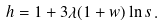<formula> <loc_0><loc_0><loc_500><loc_500>h = 1 + 3 \lambda ( 1 + w ) \ln s \, .</formula> 